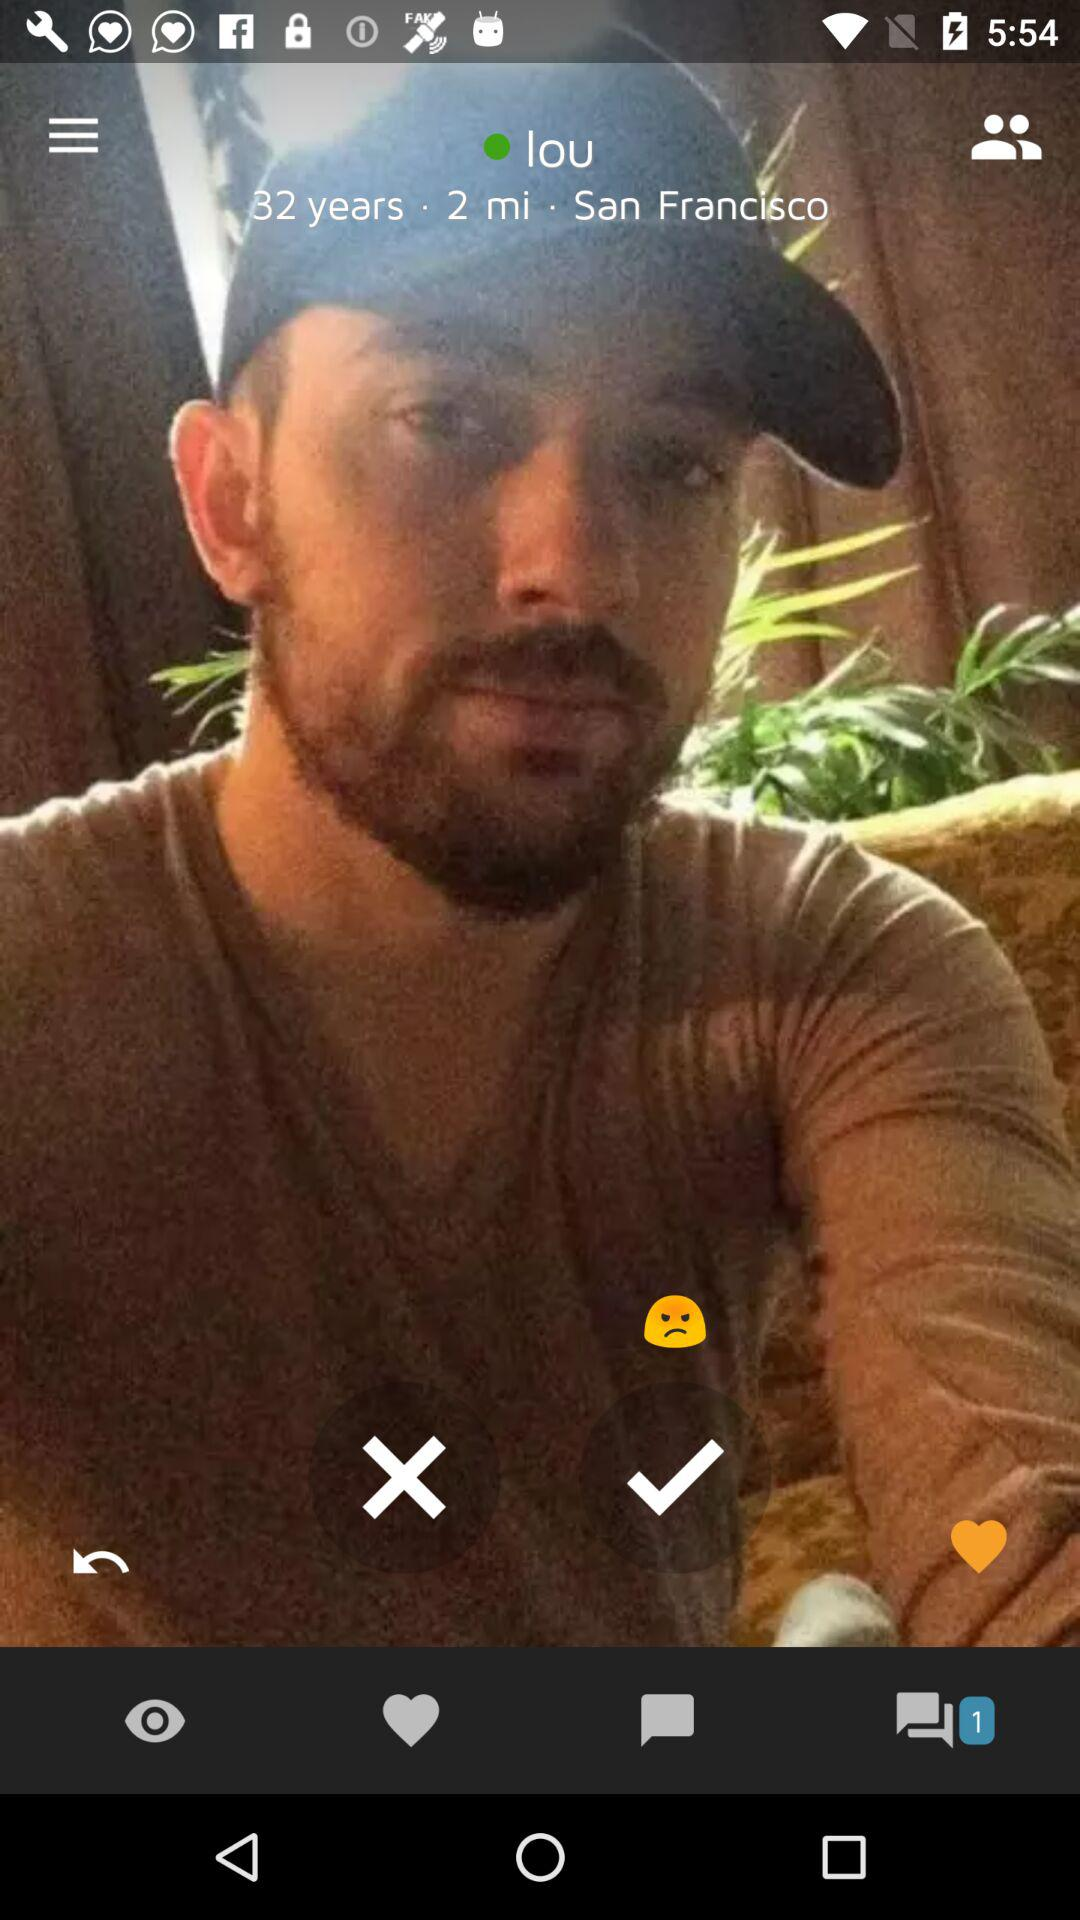What time before he clicked the picture?
When the provided information is insufficient, respond with <no answer>. <no answer> 